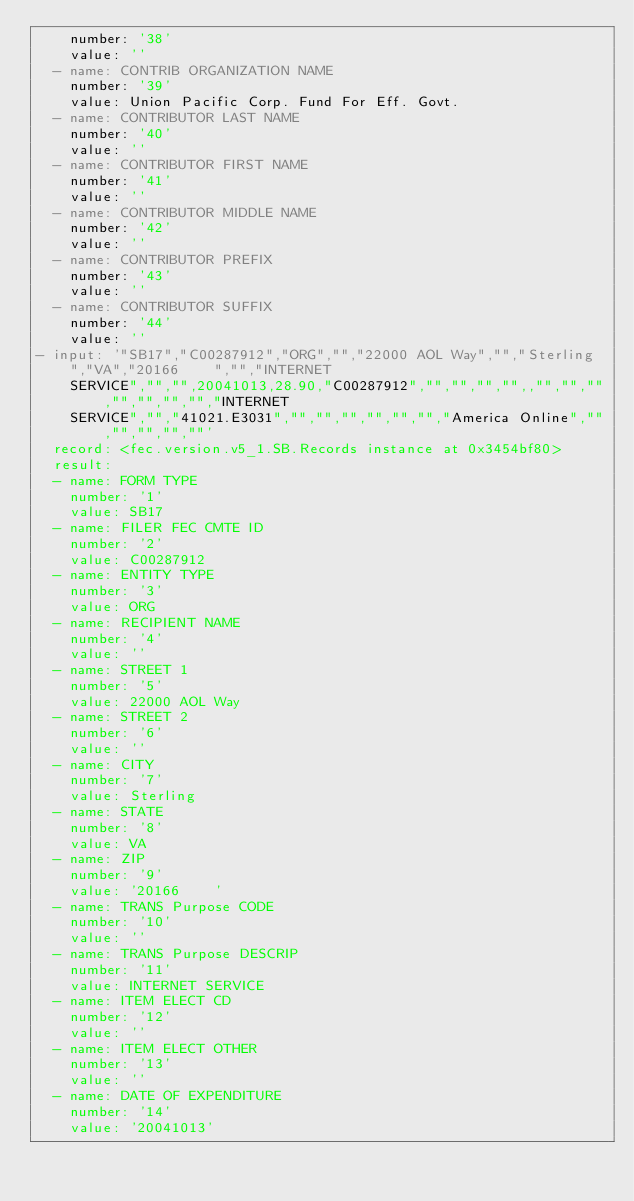<code> <loc_0><loc_0><loc_500><loc_500><_YAML_>    number: '38'
    value: ''
  - name: CONTRIB ORGANIZATION NAME
    number: '39'
    value: Union Pacific Corp. Fund For Eff. Govt.
  - name: CONTRIBUTOR LAST NAME
    number: '40'
    value: ''
  - name: CONTRIBUTOR FIRST NAME
    number: '41'
    value: ''
  - name: CONTRIBUTOR MIDDLE NAME
    number: '42'
    value: ''
  - name: CONTRIBUTOR PREFIX
    number: '43'
    value: ''
  - name: CONTRIBUTOR SUFFIX
    number: '44'
    value: ''
- input: '"SB17","C00287912","ORG","","22000 AOL Way","","Sterling","VA","20166    ","","INTERNET
    SERVICE","","",20041013,28.90,"C00287912","","","","",,"","","","","","","","INTERNET
    SERVICE","","41021.E3031","","","","","","","America Online","","","","",""'
  record: <fec.version.v5_1.SB.Records instance at 0x3454bf80>
  result:
  - name: FORM TYPE
    number: '1'
    value: SB17
  - name: FILER FEC CMTE ID
    number: '2'
    value: C00287912
  - name: ENTITY TYPE
    number: '3'
    value: ORG
  - name: RECIPIENT NAME
    number: '4'
    value: ''
  - name: STREET 1
    number: '5'
    value: 22000 AOL Way
  - name: STREET 2
    number: '6'
    value: ''
  - name: CITY
    number: '7'
    value: Sterling
  - name: STATE
    number: '8'
    value: VA
  - name: ZIP
    number: '9'
    value: '20166    '
  - name: TRANS Purpose CODE
    number: '10'
    value: ''
  - name: TRANS Purpose DESCRIP
    number: '11'
    value: INTERNET SERVICE
  - name: ITEM ELECT CD
    number: '12'
    value: ''
  - name: ITEM ELECT OTHER
    number: '13'
    value: ''
  - name: DATE OF EXPENDITURE
    number: '14'
    value: '20041013'</code> 